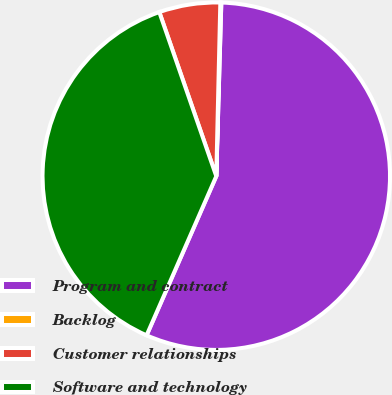Convert chart to OTSL. <chart><loc_0><loc_0><loc_500><loc_500><pie_chart><fcel>Program and contract<fcel>Backlog<fcel>Customer relationships<fcel>Software and technology<nl><fcel>56.11%<fcel>0.09%<fcel>5.69%<fcel>38.11%<nl></chart> 